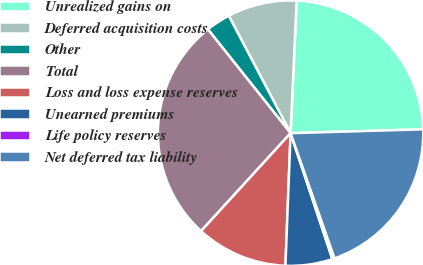<chart> <loc_0><loc_0><loc_500><loc_500><pie_chart><fcel>Unrealized gains on<fcel>Deferred acquisition costs<fcel>Other<fcel>Total<fcel>Loss and loss expense reserves<fcel>Unearned premiums<fcel>Life policy reserves<fcel>Net deferred tax liability<nl><fcel>23.81%<fcel>8.44%<fcel>2.99%<fcel>27.51%<fcel>11.17%<fcel>5.72%<fcel>0.27%<fcel>20.09%<nl></chart> 